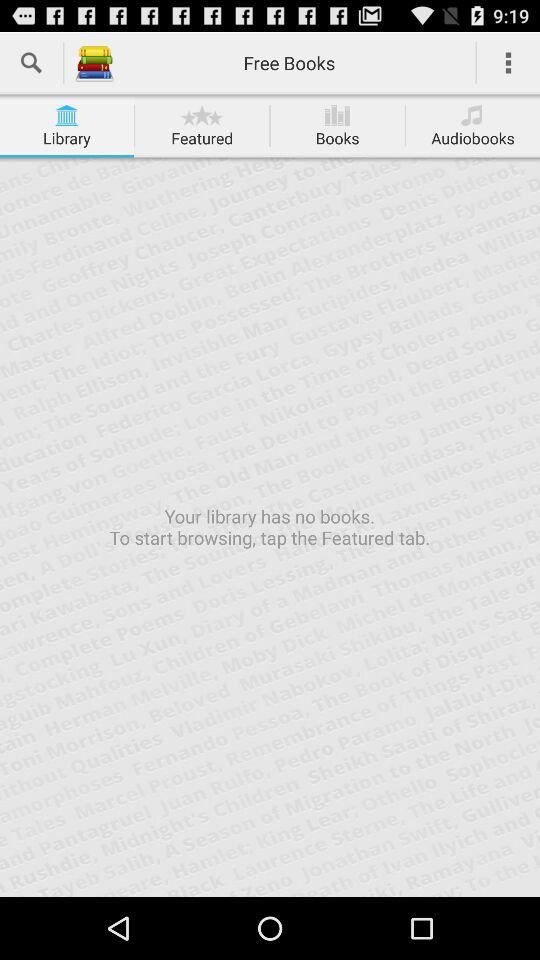How many books are in my library?
Answer the question using a single word or phrase. 0 